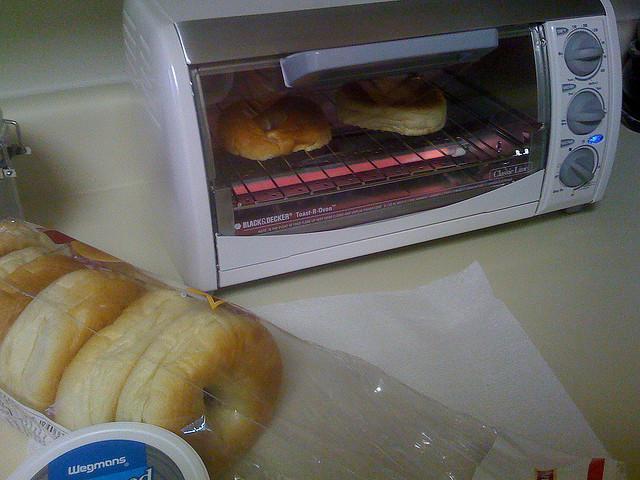Why is the bagel in there?
Indicate the correct response and explain using: 'Answer: answer
Rationale: rationale.'
Options: Warming, burning, melting, toasting. Answer: toasting.
Rationale: It is being cooked. 